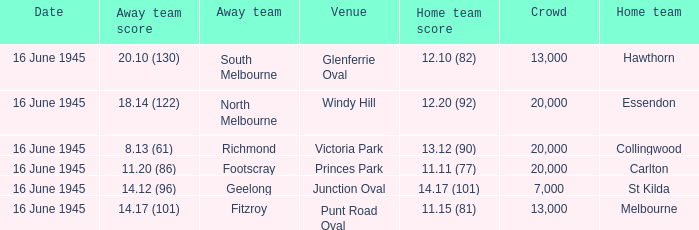What was the home team's score in the match against south melbourne? 12.10 (82). 